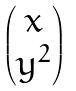<formula> <loc_0><loc_0><loc_500><loc_500>\begin{pmatrix} x \\ y ^ { 2 } \end{pmatrix}</formula> 